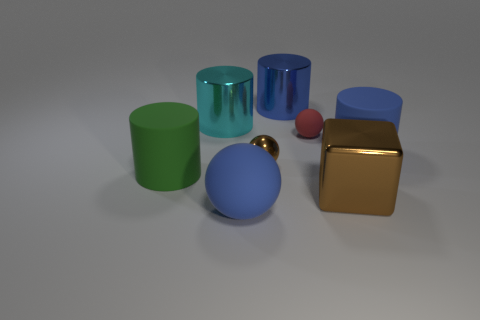Subtract all small spheres. How many spheres are left? 1 Add 1 blocks. How many objects exist? 9 Subtract all green cylinders. How many cylinders are left? 3 Subtract all purple cubes. How many blue cylinders are left? 2 Add 1 cylinders. How many cylinders are left? 5 Add 4 cyan cylinders. How many cyan cylinders exist? 5 Subtract 2 blue cylinders. How many objects are left? 6 Subtract all spheres. How many objects are left? 5 Subtract 1 blocks. How many blocks are left? 0 Subtract all blue blocks. Subtract all green cylinders. How many blocks are left? 1 